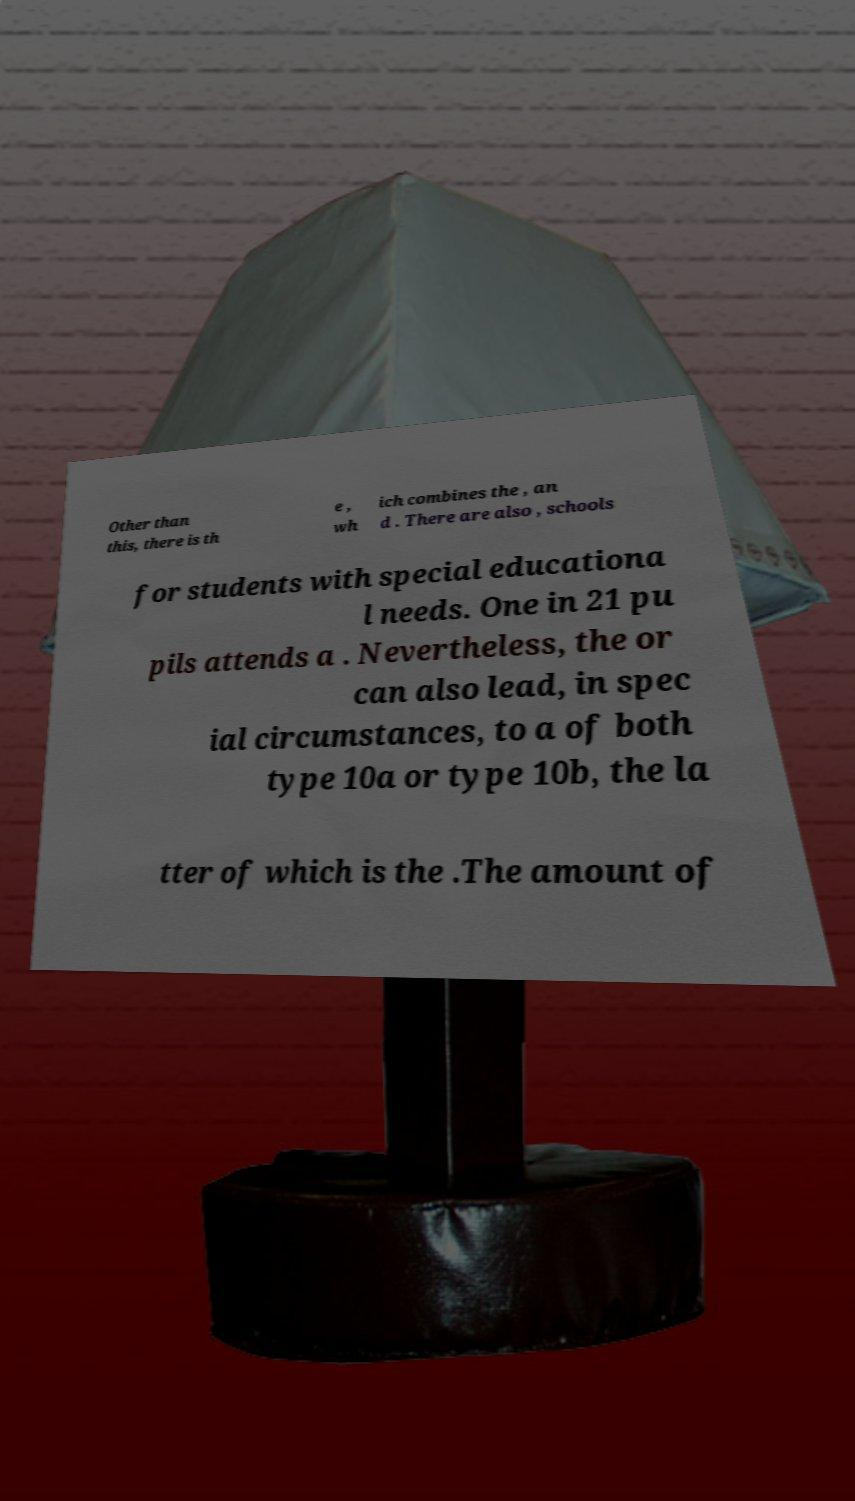There's text embedded in this image that I need extracted. Can you transcribe it verbatim? Other than this, there is th e , wh ich combines the , an d . There are also , schools for students with special educationa l needs. One in 21 pu pils attends a . Nevertheless, the or can also lead, in spec ial circumstances, to a of both type 10a or type 10b, the la tter of which is the .The amount of 